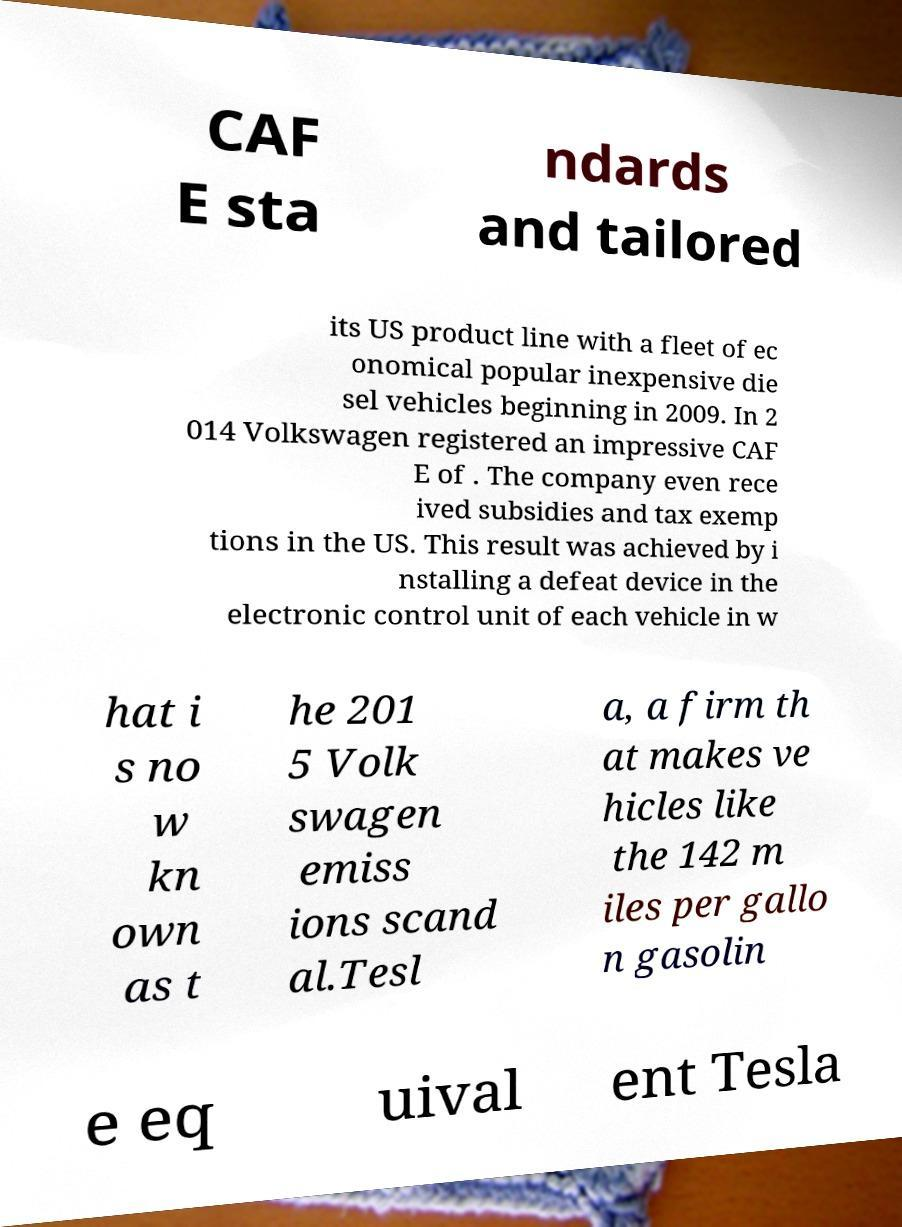What messages or text are displayed in this image? I need them in a readable, typed format. CAF E sta ndards and tailored its US product line with a fleet of ec onomical popular inexpensive die sel vehicles beginning in 2009. In 2 014 Volkswagen registered an impressive CAF E of . The company even rece ived subsidies and tax exemp tions in the US. This result was achieved by i nstalling a defeat device in the electronic control unit of each vehicle in w hat i s no w kn own as t he 201 5 Volk swagen emiss ions scand al.Tesl a, a firm th at makes ve hicles like the 142 m iles per gallo n gasolin e eq uival ent Tesla 